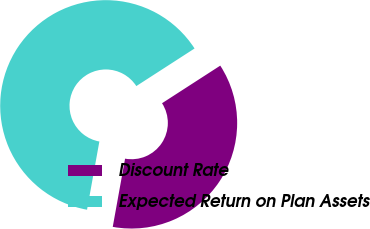Convert chart to OTSL. <chart><loc_0><loc_0><loc_500><loc_500><pie_chart><fcel>Discount Rate<fcel>Expected Return on Plan Assets<nl><fcel>36.97%<fcel>63.03%<nl></chart> 